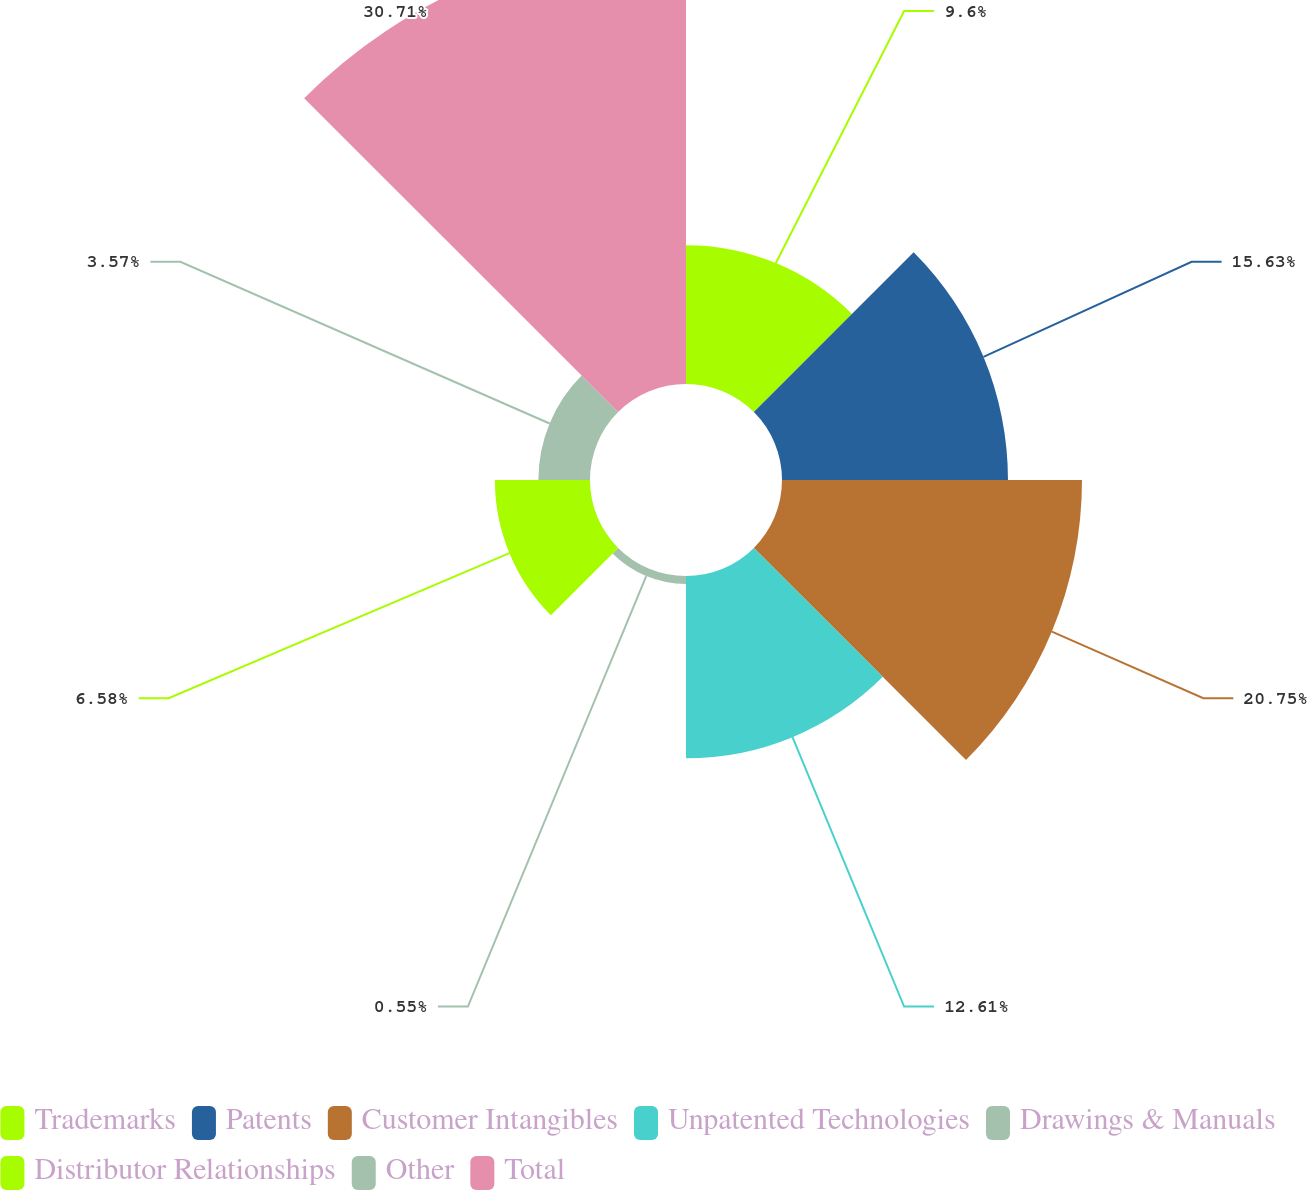Convert chart to OTSL. <chart><loc_0><loc_0><loc_500><loc_500><pie_chart><fcel>Trademarks<fcel>Patents<fcel>Customer Intangibles<fcel>Unpatented Technologies<fcel>Drawings & Manuals<fcel>Distributor Relationships<fcel>Other<fcel>Total<nl><fcel>9.6%<fcel>15.63%<fcel>20.75%<fcel>12.61%<fcel>0.55%<fcel>6.58%<fcel>3.57%<fcel>30.71%<nl></chart> 